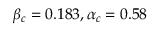<formula> <loc_0><loc_0><loc_500><loc_500>\beta _ { c } = 0 . 1 8 3 , \alpha _ { c } = 0 . 5 8</formula> 